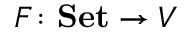Convert formula to latex. <formula><loc_0><loc_0><loc_500><loc_500>F \colon S e t \to V</formula> 